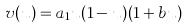Convert formula to latex. <formula><loc_0><loc_0><loc_500><loc_500>v ( u ) = a _ { 1 } u ( 1 - u ) ( 1 + b u )</formula> 